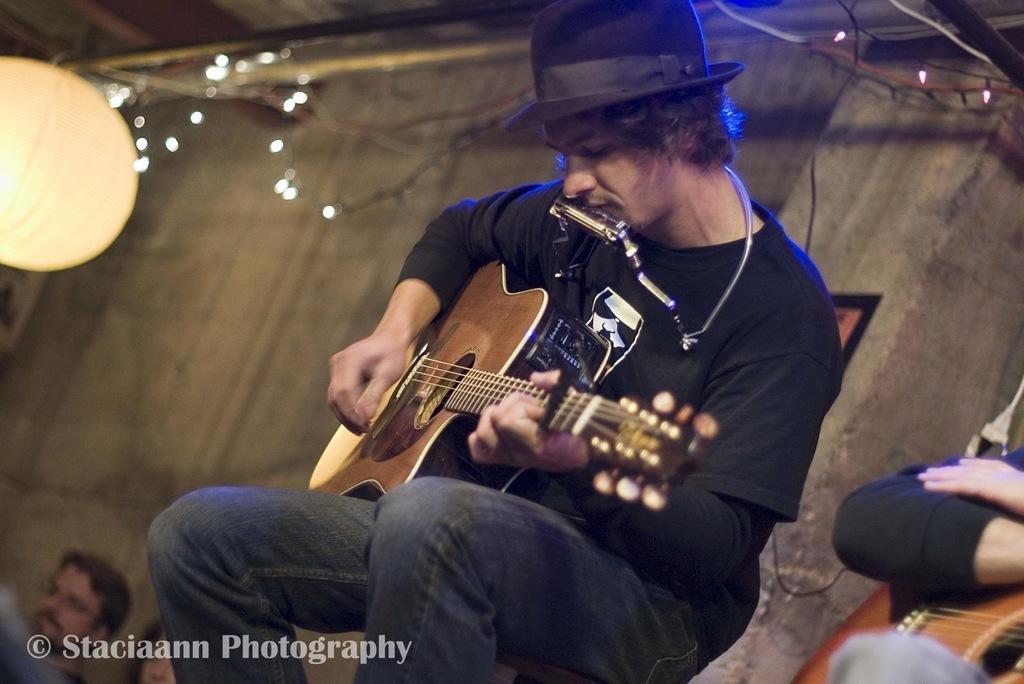Can you describe this image briefly? In this picture there is a man in the center of the image, he is playing guitar and there is another person in the bottom right side of the image, there are lights at the top side of the image. 